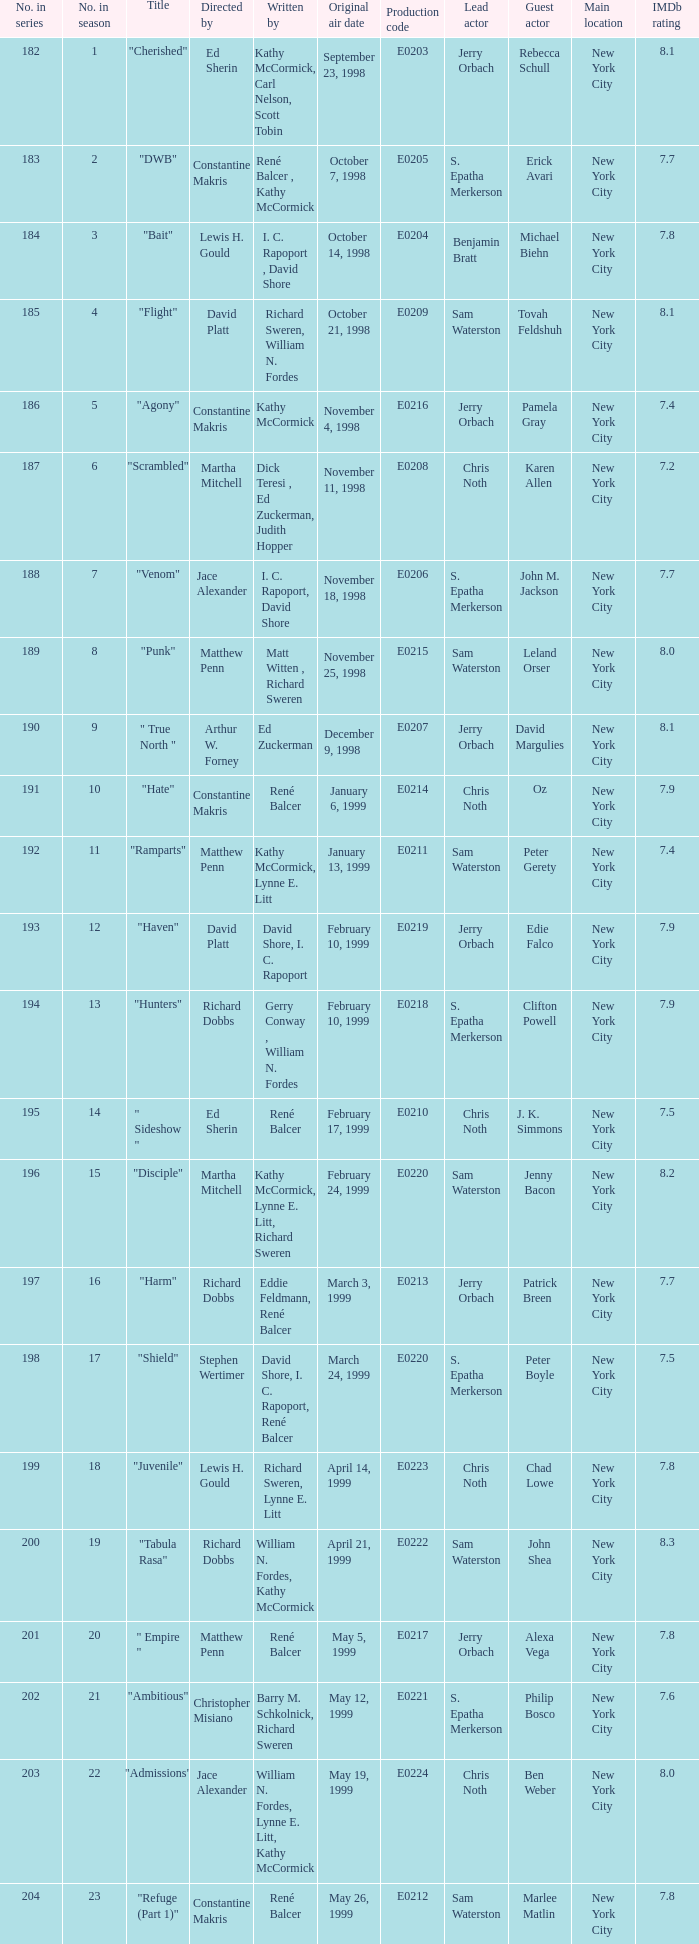The episode with the title "Bait" has what original air date? October 14, 1998. 